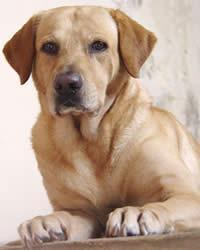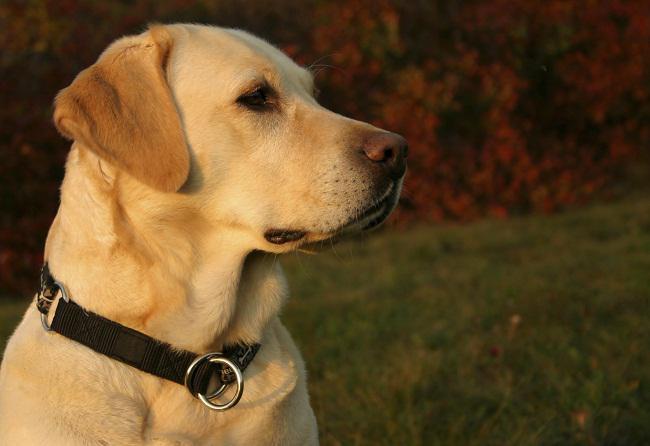The first image is the image on the left, the second image is the image on the right. Analyze the images presented: Is the assertion "One of the animals is not on the grass." valid? Answer yes or no. Yes. 